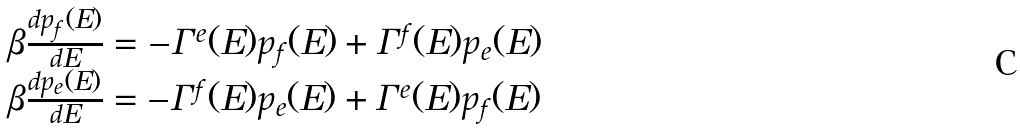Convert formula to latex. <formula><loc_0><loc_0><loc_500><loc_500>\begin{array} { l } \beta \frac { d p _ { f } ( E ) } { d E } = - \Gamma ^ { e } ( E ) p _ { f } ( E ) + \Gamma ^ { f } ( E ) p _ { e } ( E ) \\ \beta \frac { d p _ { e } ( E ) } { d E } = - \Gamma ^ { f } ( E ) p _ { e } ( E ) + \Gamma ^ { e } ( E ) p _ { f } ( E ) \end{array}</formula> 